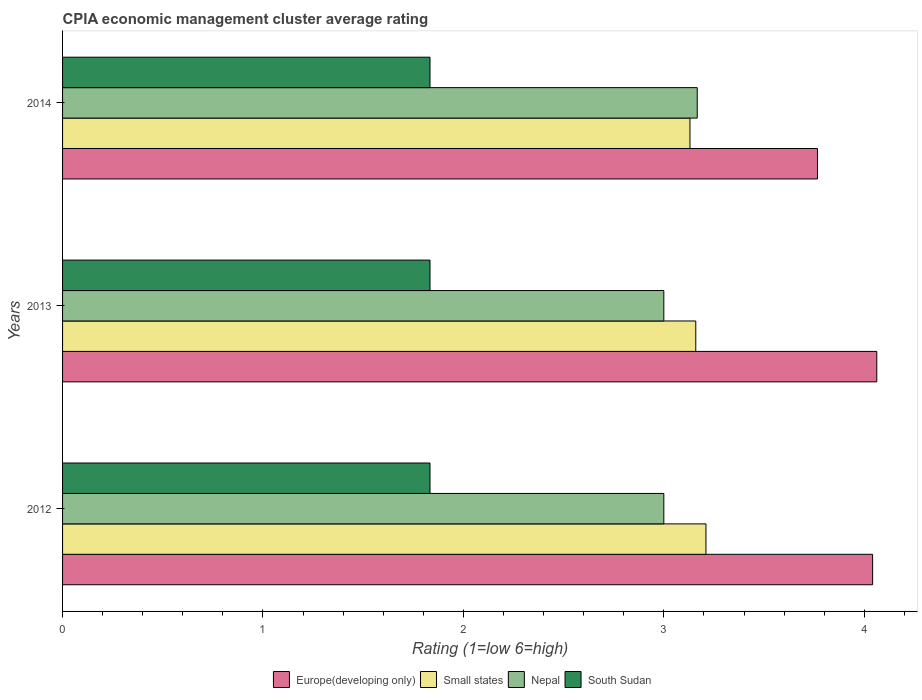How many groups of bars are there?
Provide a succinct answer. 3. Are the number of bars per tick equal to the number of legend labels?
Give a very brief answer. Yes. Are the number of bars on each tick of the Y-axis equal?
Your answer should be very brief. Yes. How many bars are there on the 3rd tick from the bottom?
Offer a very short reply. 4. In how many cases, is the number of bars for a given year not equal to the number of legend labels?
Your answer should be very brief. 0. What is the CPIA rating in South Sudan in 2013?
Make the answer very short. 1.83. Across all years, what is the maximum CPIA rating in South Sudan?
Provide a succinct answer. 1.83. Across all years, what is the minimum CPIA rating in South Sudan?
Your answer should be compact. 1.83. In which year was the CPIA rating in Europe(developing only) maximum?
Make the answer very short. 2013. What is the total CPIA rating in Small states in the graph?
Offer a very short reply. 9.5. What is the difference between the CPIA rating in South Sudan in 2012 and that in 2013?
Ensure brevity in your answer.  0. What is the difference between the CPIA rating in South Sudan in 2014 and the CPIA rating in Small states in 2012?
Ensure brevity in your answer.  -1.38. What is the average CPIA rating in Europe(developing only) per year?
Make the answer very short. 3.96. In the year 2013, what is the difference between the CPIA rating in Europe(developing only) and CPIA rating in South Sudan?
Ensure brevity in your answer.  2.23. What is the ratio of the CPIA rating in Nepal in 2012 to that in 2014?
Provide a succinct answer. 0.95. Is the difference between the CPIA rating in Europe(developing only) in 2012 and 2014 greater than the difference between the CPIA rating in South Sudan in 2012 and 2014?
Your answer should be very brief. Yes. What is the difference between the highest and the second highest CPIA rating in Europe(developing only)?
Your response must be concise. 0.02. What is the difference between the highest and the lowest CPIA rating in Small states?
Provide a succinct answer. 0.08. In how many years, is the CPIA rating in Small states greater than the average CPIA rating in Small states taken over all years?
Your response must be concise. 1. Is it the case that in every year, the sum of the CPIA rating in South Sudan and CPIA rating in Nepal is greater than the sum of CPIA rating in Europe(developing only) and CPIA rating in Small states?
Ensure brevity in your answer.  Yes. What does the 3rd bar from the top in 2013 represents?
Provide a succinct answer. Small states. What does the 1st bar from the bottom in 2014 represents?
Ensure brevity in your answer.  Europe(developing only). Is it the case that in every year, the sum of the CPIA rating in Europe(developing only) and CPIA rating in Nepal is greater than the CPIA rating in South Sudan?
Give a very brief answer. Yes. Are all the bars in the graph horizontal?
Provide a succinct answer. Yes. How many years are there in the graph?
Make the answer very short. 3. Does the graph contain grids?
Give a very brief answer. No. How many legend labels are there?
Your answer should be very brief. 4. What is the title of the graph?
Your response must be concise. CPIA economic management cluster average rating. What is the Rating (1=low 6=high) of Europe(developing only) in 2012?
Your answer should be compact. 4.04. What is the Rating (1=low 6=high) of Small states in 2012?
Provide a succinct answer. 3.21. What is the Rating (1=low 6=high) in South Sudan in 2012?
Offer a very short reply. 1.83. What is the Rating (1=low 6=high) of Europe(developing only) in 2013?
Ensure brevity in your answer.  4.06. What is the Rating (1=low 6=high) in Small states in 2013?
Provide a short and direct response. 3.16. What is the Rating (1=low 6=high) in South Sudan in 2013?
Ensure brevity in your answer.  1.83. What is the Rating (1=low 6=high) in Europe(developing only) in 2014?
Give a very brief answer. 3.77. What is the Rating (1=low 6=high) in Small states in 2014?
Your answer should be very brief. 3.13. What is the Rating (1=low 6=high) in Nepal in 2014?
Give a very brief answer. 3.17. What is the Rating (1=low 6=high) of South Sudan in 2014?
Ensure brevity in your answer.  1.83. Across all years, what is the maximum Rating (1=low 6=high) of Europe(developing only)?
Offer a terse response. 4.06. Across all years, what is the maximum Rating (1=low 6=high) in Small states?
Ensure brevity in your answer.  3.21. Across all years, what is the maximum Rating (1=low 6=high) in Nepal?
Offer a very short reply. 3.17. Across all years, what is the maximum Rating (1=low 6=high) of South Sudan?
Offer a very short reply. 1.83. Across all years, what is the minimum Rating (1=low 6=high) in Europe(developing only)?
Give a very brief answer. 3.77. Across all years, what is the minimum Rating (1=low 6=high) in Small states?
Provide a short and direct response. 3.13. Across all years, what is the minimum Rating (1=low 6=high) in Nepal?
Your answer should be compact. 3. Across all years, what is the minimum Rating (1=low 6=high) in South Sudan?
Offer a very short reply. 1.83. What is the total Rating (1=low 6=high) of Europe(developing only) in the graph?
Offer a very short reply. 11.87. What is the total Rating (1=low 6=high) in Nepal in the graph?
Make the answer very short. 9.17. What is the total Rating (1=low 6=high) of South Sudan in the graph?
Your answer should be very brief. 5.5. What is the difference between the Rating (1=low 6=high) of Europe(developing only) in 2012 and that in 2013?
Provide a succinct answer. -0.02. What is the difference between the Rating (1=low 6=high) of Small states in 2012 and that in 2013?
Make the answer very short. 0.05. What is the difference between the Rating (1=low 6=high) in Europe(developing only) in 2012 and that in 2014?
Offer a very short reply. 0.28. What is the difference between the Rating (1=low 6=high) in Small states in 2012 and that in 2014?
Your answer should be very brief. 0.08. What is the difference between the Rating (1=low 6=high) of Nepal in 2012 and that in 2014?
Provide a succinct answer. -0.17. What is the difference between the Rating (1=low 6=high) of South Sudan in 2012 and that in 2014?
Offer a terse response. 0. What is the difference between the Rating (1=low 6=high) in Europe(developing only) in 2013 and that in 2014?
Make the answer very short. 0.3. What is the difference between the Rating (1=low 6=high) in Small states in 2013 and that in 2014?
Provide a succinct answer. 0.03. What is the difference between the Rating (1=low 6=high) in South Sudan in 2013 and that in 2014?
Ensure brevity in your answer.  0. What is the difference between the Rating (1=low 6=high) in Europe(developing only) in 2012 and the Rating (1=low 6=high) in Small states in 2013?
Your response must be concise. 0.88. What is the difference between the Rating (1=low 6=high) in Europe(developing only) in 2012 and the Rating (1=low 6=high) in Nepal in 2013?
Your answer should be very brief. 1.04. What is the difference between the Rating (1=low 6=high) in Europe(developing only) in 2012 and the Rating (1=low 6=high) in South Sudan in 2013?
Your answer should be very brief. 2.21. What is the difference between the Rating (1=low 6=high) in Small states in 2012 and the Rating (1=low 6=high) in Nepal in 2013?
Provide a short and direct response. 0.21. What is the difference between the Rating (1=low 6=high) of Small states in 2012 and the Rating (1=low 6=high) of South Sudan in 2013?
Keep it short and to the point. 1.38. What is the difference between the Rating (1=low 6=high) in Europe(developing only) in 2012 and the Rating (1=low 6=high) in Small states in 2014?
Offer a very short reply. 0.91. What is the difference between the Rating (1=low 6=high) in Europe(developing only) in 2012 and the Rating (1=low 6=high) in South Sudan in 2014?
Make the answer very short. 2.21. What is the difference between the Rating (1=low 6=high) in Small states in 2012 and the Rating (1=low 6=high) in Nepal in 2014?
Make the answer very short. 0.04. What is the difference between the Rating (1=low 6=high) of Small states in 2012 and the Rating (1=low 6=high) of South Sudan in 2014?
Your answer should be compact. 1.38. What is the difference between the Rating (1=low 6=high) of Nepal in 2012 and the Rating (1=low 6=high) of South Sudan in 2014?
Your answer should be very brief. 1.17. What is the difference between the Rating (1=low 6=high) of Europe(developing only) in 2013 and the Rating (1=low 6=high) of Small states in 2014?
Provide a succinct answer. 0.93. What is the difference between the Rating (1=low 6=high) in Europe(developing only) in 2013 and the Rating (1=low 6=high) in Nepal in 2014?
Keep it short and to the point. 0.9. What is the difference between the Rating (1=low 6=high) in Europe(developing only) in 2013 and the Rating (1=low 6=high) in South Sudan in 2014?
Ensure brevity in your answer.  2.23. What is the difference between the Rating (1=low 6=high) in Small states in 2013 and the Rating (1=low 6=high) in Nepal in 2014?
Offer a very short reply. -0.01. What is the difference between the Rating (1=low 6=high) in Small states in 2013 and the Rating (1=low 6=high) in South Sudan in 2014?
Your response must be concise. 1.33. What is the average Rating (1=low 6=high) in Europe(developing only) per year?
Keep it short and to the point. 3.96. What is the average Rating (1=low 6=high) in Small states per year?
Ensure brevity in your answer.  3.17. What is the average Rating (1=low 6=high) in Nepal per year?
Your answer should be compact. 3.06. What is the average Rating (1=low 6=high) in South Sudan per year?
Make the answer very short. 1.83. In the year 2012, what is the difference between the Rating (1=low 6=high) in Europe(developing only) and Rating (1=low 6=high) in Small states?
Offer a terse response. 0.83. In the year 2012, what is the difference between the Rating (1=low 6=high) in Europe(developing only) and Rating (1=low 6=high) in Nepal?
Keep it short and to the point. 1.04. In the year 2012, what is the difference between the Rating (1=low 6=high) in Europe(developing only) and Rating (1=low 6=high) in South Sudan?
Provide a succinct answer. 2.21. In the year 2012, what is the difference between the Rating (1=low 6=high) in Small states and Rating (1=low 6=high) in Nepal?
Give a very brief answer. 0.21. In the year 2012, what is the difference between the Rating (1=low 6=high) in Small states and Rating (1=low 6=high) in South Sudan?
Your answer should be very brief. 1.38. In the year 2012, what is the difference between the Rating (1=low 6=high) in Nepal and Rating (1=low 6=high) in South Sudan?
Offer a very short reply. 1.17. In the year 2013, what is the difference between the Rating (1=low 6=high) of Europe(developing only) and Rating (1=low 6=high) of Small states?
Make the answer very short. 0.9. In the year 2013, what is the difference between the Rating (1=low 6=high) in Europe(developing only) and Rating (1=low 6=high) in South Sudan?
Keep it short and to the point. 2.23. In the year 2013, what is the difference between the Rating (1=low 6=high) of Small states and Rating (1=low 6=high) of Nepal?
Offer a terse response. 0.16. In the year 2013, what is the difference between the Rating (1=low 6=high) in Small states and Rating (1=low 6=high) in South Sudan?
Your response must be concise. 1.33. In the year 2013, what is the difference between the Rating (1=low 6=high) of Nepal and Rating (1=low 6=high) of South Sudan?
Your answer should be very brief. 1.17. In the year 2014, what is the difference between the Rating (1=low 6=high) of Europe(developing only) and Rating (1=low 6=high) of Small states?
Keep it short and to the point. 0.64. In the year 2014, what is the difference between the Rating (1=low 6=high) in Europe(developing only) and Rating (1=low 6=high) in South Sudan?
Provide a short and direct response. 1.93. In the year 2014, what is the difference between the Rating (1=low 6=high) in Small states and Rating (1=low 6=high) in Nepal?
Offer a very short reply. -0.04. In the year 2014, what is the difference between the Rating (1=low 6=high) in Small states and Rating (1=low 6=high) in South Sudan?
Ensure brevity in your answer.  1.3. What is the ratio of the Rating (1=low 6=high) of Europe(developing only) in 2012 to that in 2013?
Provide a short and direct response. 0.99. What is the ratio of the Rating (1=low 6=high) of Small states in 2012 to that in 2013?
Ensure brevity in your answer.  1.02. What is the ratio of the Rating (1=low 6=high) of Europe(developing only) in 2012 to that in 2014?
Offer a very short reply. 1.07. What is the ratio of the Rating (1=low 6=high) in Small states in 2012 to that in 2014?
Make the answer very short. 1.03. What is the ratio of the Rating (1=low 6=high) in Nepal in 2012 to that in 2014?
Offer a very short reply. 0.95. What is the ratio of the Rating (1=low 6=high) in South Sudan in 2012 to that in 2014?
Your response must be concise. 1. What is the ratio of the Rating (1=low 6=high) of Europe(developing only) in 2013 to that in 2014?
Make the answer very short. 1.08. What is the ratio of the Rating (1=low 6=high) of Small states in 2013 to that in 2014?
Provide a succinct answer. 1.01. What is the ratio of the Rating (1=low 6=high) in Nepal in 2013 to that in 2014?
Give a very brief answer. 0.95. What is the difference between the highest and the second highest Rating (1=low 6=high) of Europe(developing only)?
Provide a short and direct response. 0.02. What is the difference between the highest and the second highest Rating (1=low 6=high) in Small states?
Your answer should be very brief. 0.05. What is the difference between the highest and the second highest Rating (1=low 6=high) in Nepal?
Your answer should be compact. 0.17. What is the difference between the highest and the lowest Rating (1=low 6=high) in Europe(developing only)?
Provide a short and direct response. 0.3. What is the difference between the highest and the lowest Rating (1=low 6=high) of Small states?
Keep it short and to the point. 0.08. 